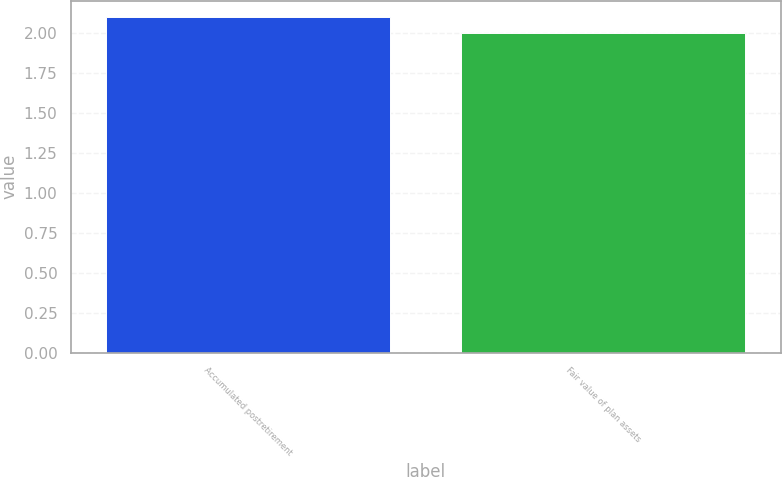Convert chart to OTSL. <chart><loc_0><loc_0><loc_500><loc_500><bar_chart><fcel>Accumulated postretirement<fcel>Fair value of plan assets<nl><fcel>2.1<fcel>2<nl></chart> 